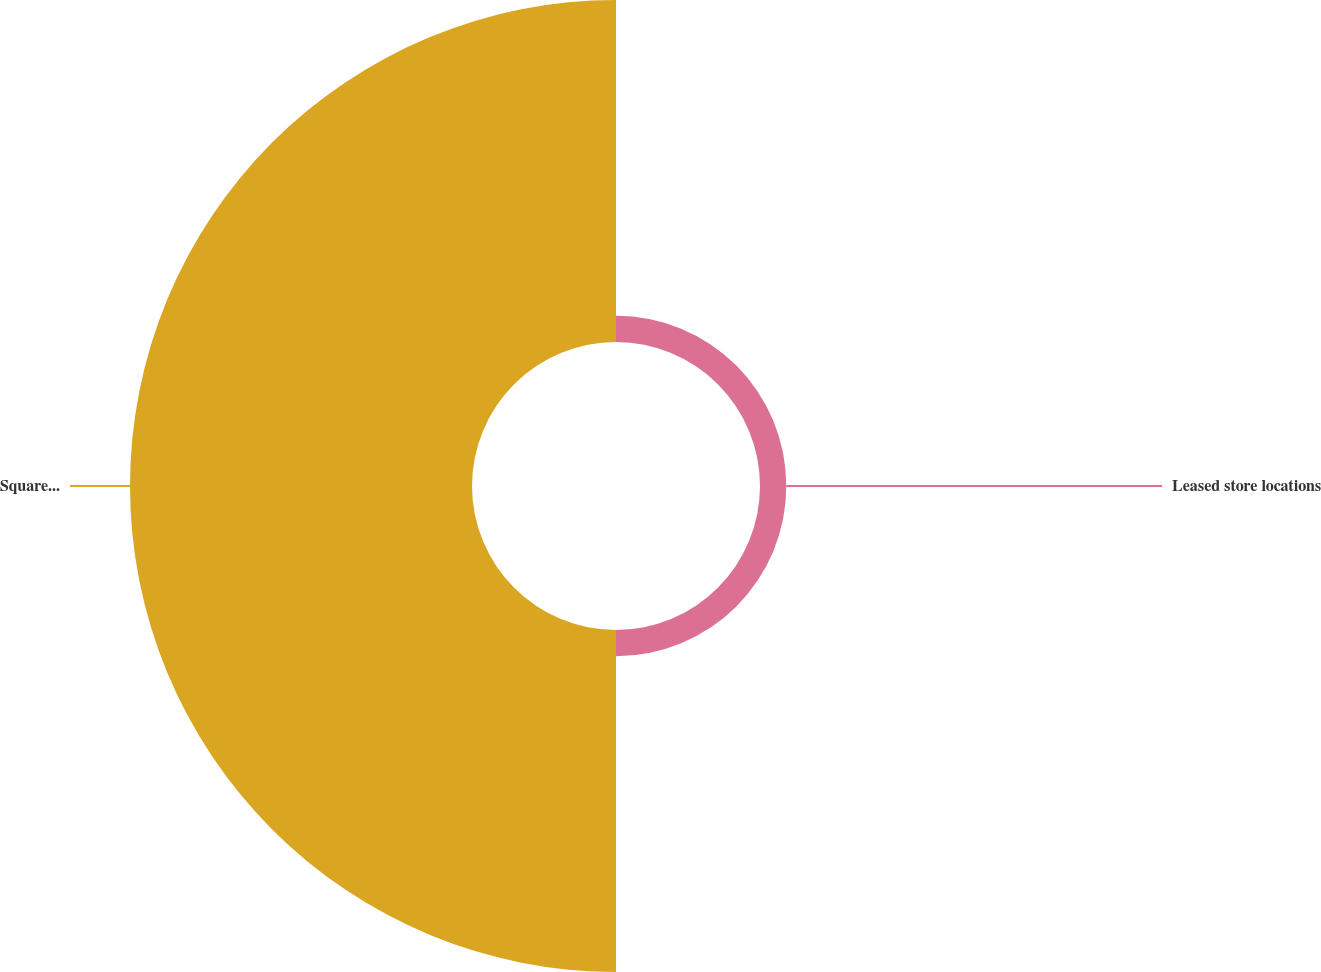Convert chart. <chart><loc_0><loc_0><loc_500><loc_500><pie_chart><fcel>Leased store locations<fcel>Square footage (in thousands)<nl><fcel>7.14%<fcel>92.86%<nl></chart> 